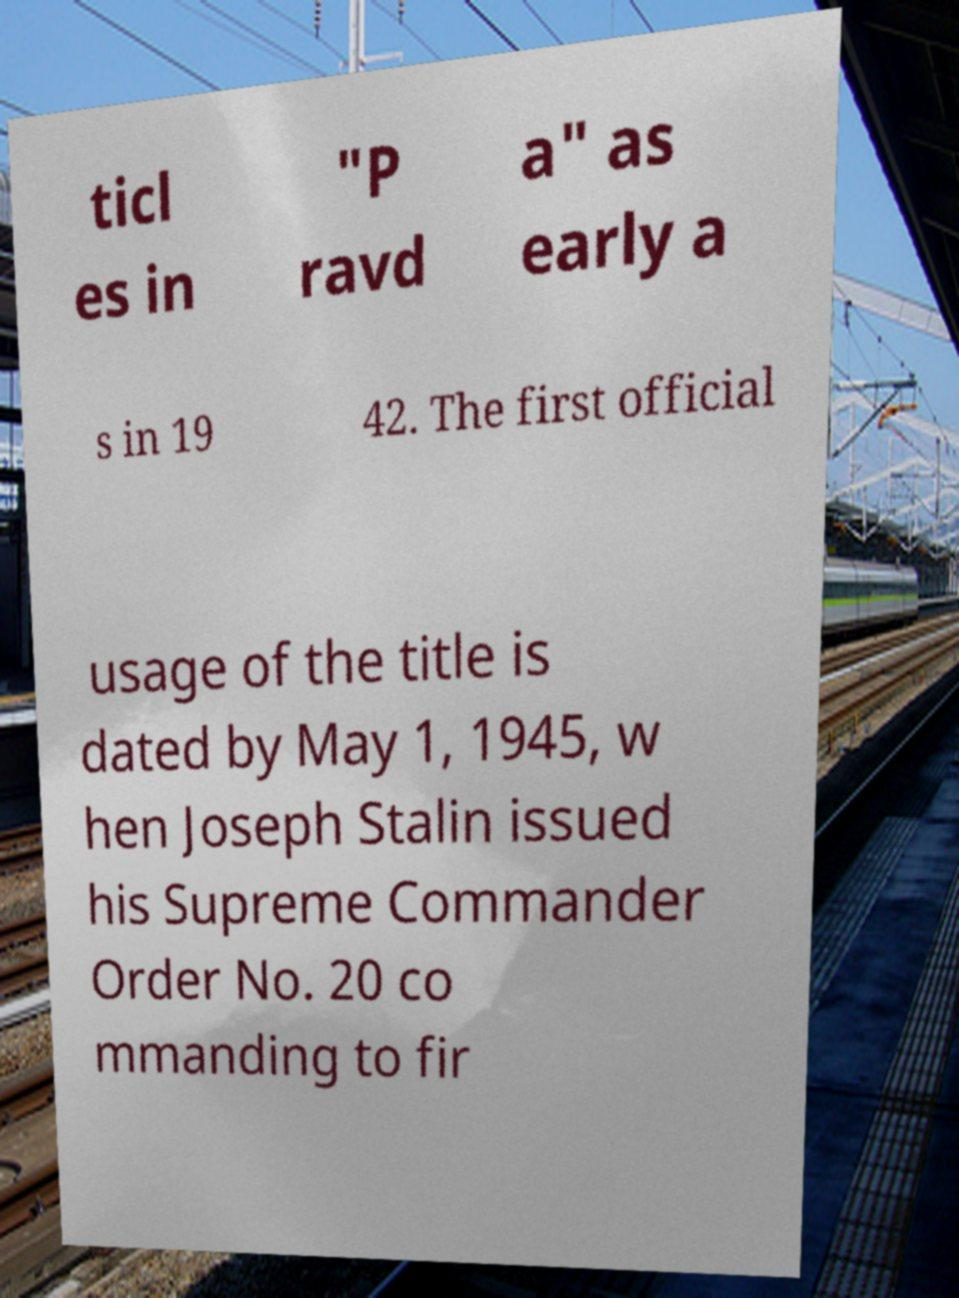Can you read and provide the text displayed in the image?This photo seems to have some interesting text. Can you extract and type it out for me? ticl es in "P ravd a" as early a s in 19 42. The first official usage of the title is dated by May 1, 1945, w hen Joseph Stalin issued his Supreme Commander Order No. 20 co mmanding to fir 